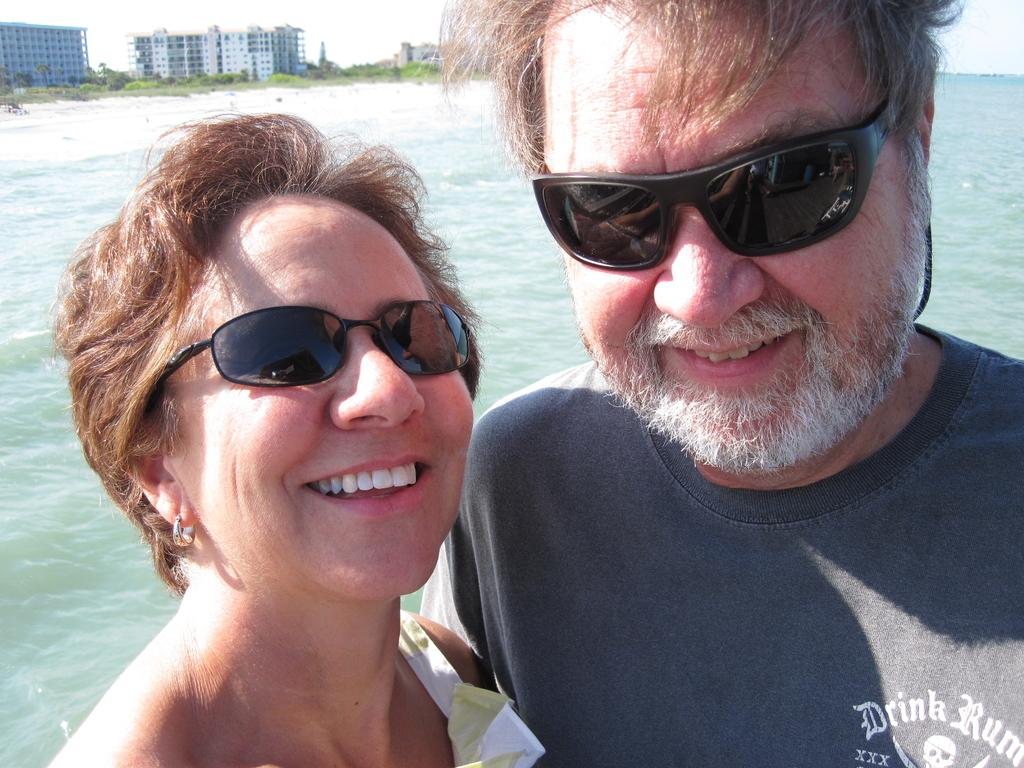What is the man in the image wearing on his upper body? The man is wearing a grey t-shirt. What is the man wearing on his face in the image? The man is wearing goggles. What is the man's facial expression in the image? The man is smiling. Who else is present in the image? There is a woman in the image. What can be seen in the background of the image? There is a sea and buildings in the background of the image. What type of rings can be seen on the man's fingers in the image? There are no rings visible on the man's fingers in the image. What type of pan is being used by the man in the image? There is no pan present in the image; the man is wearing goggles and a grey t-shirt. 